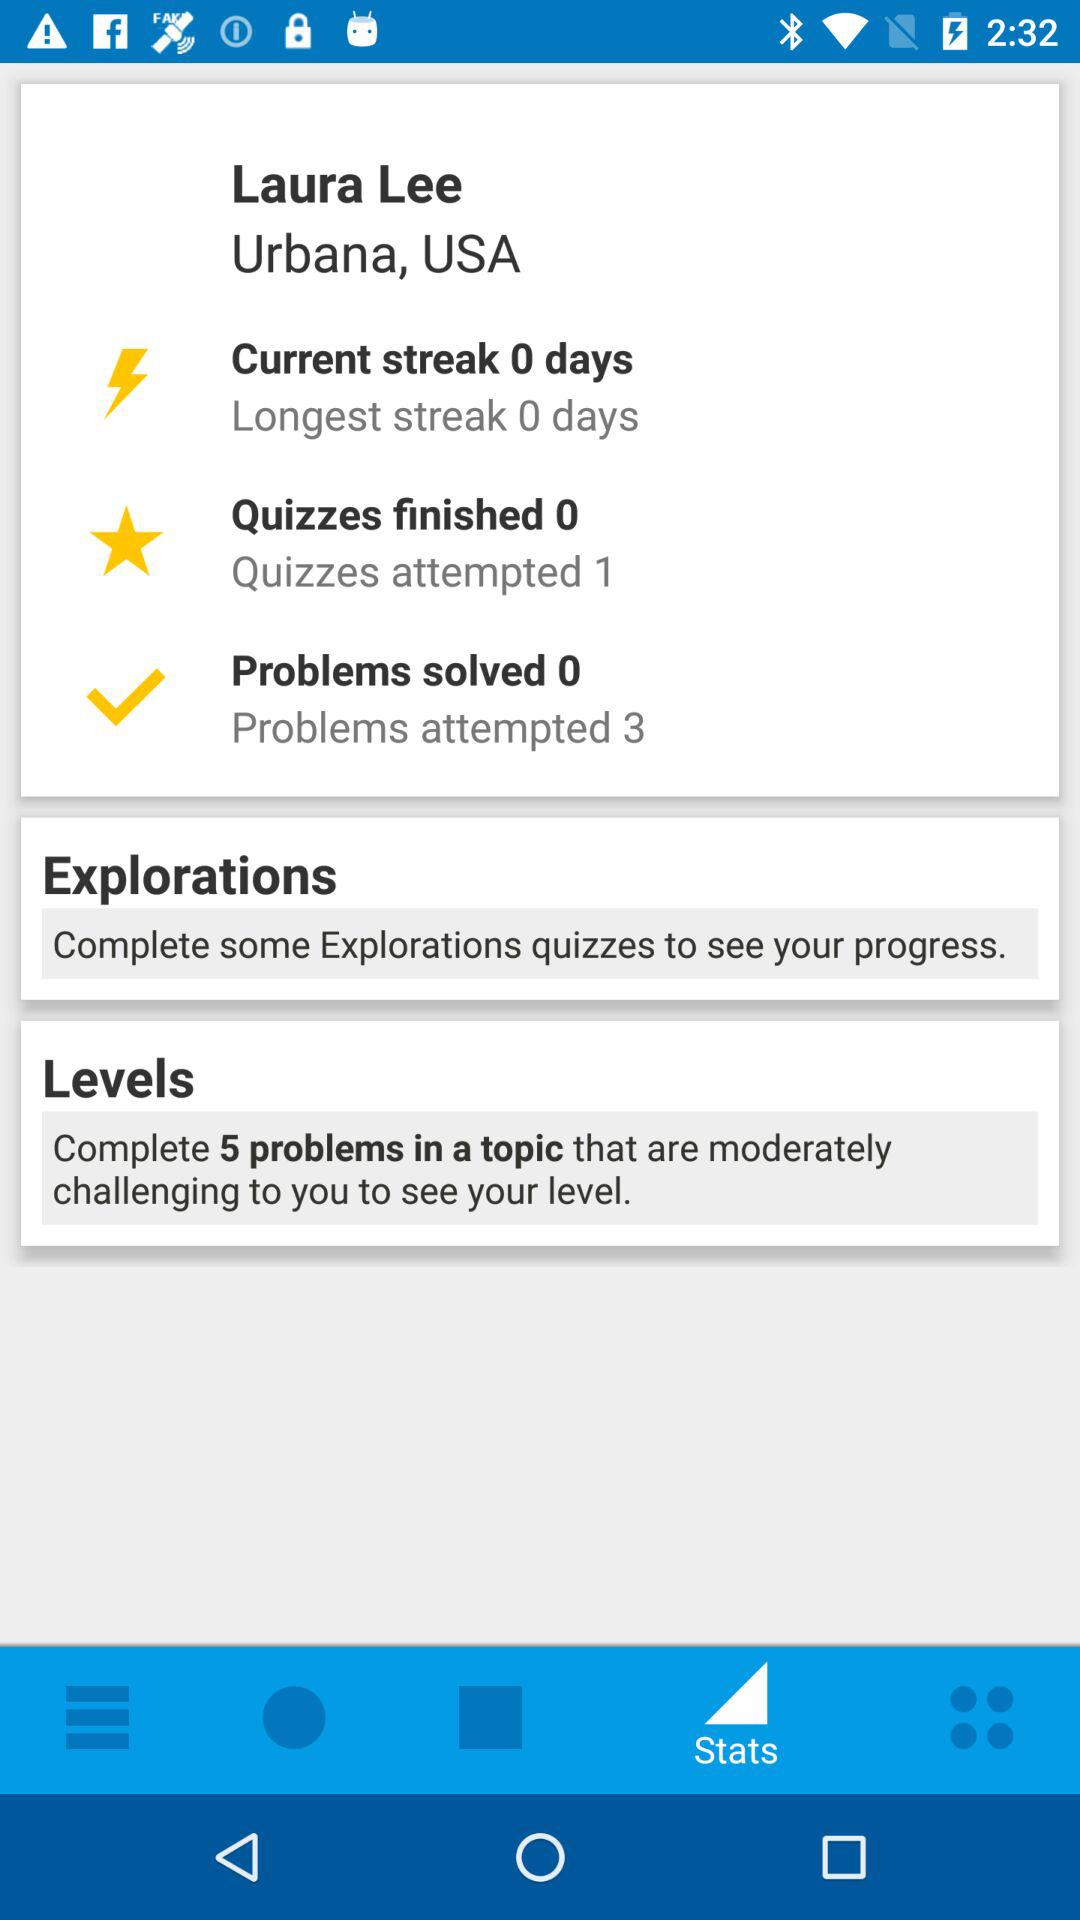How many attempts left to solve problem?
When the provided information is insufficient, respond with <no answer>. <no answer> 